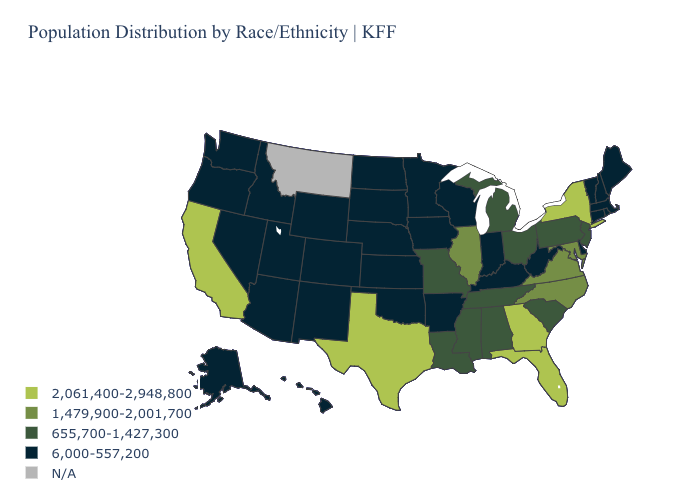What is the value of Alabama?
Quick response, please. 655,700-1,427,300. Name the states that have a value in the range 2,061,400-2,948,800?
Quick response, please. California, Florida, Georgia, New York, Texas. Name the states that have a value in the range 2,061,400-2,948,800?
Be succinct. California, Florida, Georgia, New York, Texas. How many symbols are there in the legend?
Give a very brief answer. 5. What is the lowest value in the South?
Keep it brief. 6,000-557,200. Does Vermont have the lowest value in the Northeast?
Short answer required. Yes. Among the states that border Oklahoma , which have the lowest value?
Concise answer only. Arkansas, Colorado, Kansas, New Mexico. Which states hav the highest value in the Northeast?
Write a very short answer. New York. Name the states that have a value in the range 1,479,900-2,001,700?
Write a very short answer. Illinois, Maryland, North Carolina, Virginia. Name the states that have a value in the range 1,479,900-2,001,700?
Write a very short answer. Illinois, Maryland, North Carolina, Virginia. What is the value of Michigan?
Quick response, please. 655,700-1,427,300. Name the states that have a value in the range 6,000-557,200?
Answer briefly. Alaska, Arizona, Arkansas, Colorado, Connecticut, Delaware, Hawaii, Idaho, Indiana, Iowa, Kansas, Kentucky, Maine, Massachusetts, Minnesota, Nebraska, Nevada, New Hampshire, New Mexico, North Dakota, Oklahoma, Oregon, Rhode Island, South Dakota, Utah, Vermont, Washington, West Virginia, Wisconsin, Wyoming. What is the value of New York?
Answer briefly. 2,061,400-2,948,800. Which states have the highest value in the USA?
Answer briefly. California, Florida, Georgia, New York, Texas. 